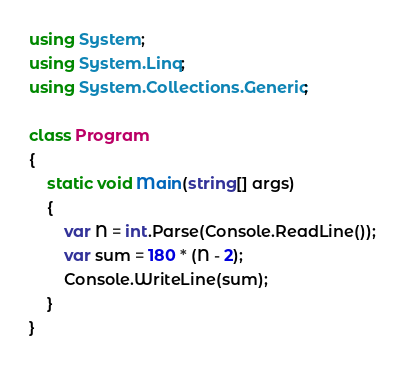<code> <loc_0><loc_0><loc_500><loc_500><_C#_>using System;
using System.Linq;
using System.Collections.Generic;

class Program
{
    static void Main(string[] args)
    {
        var N = int.Parse(Console.ReadLine());
        var sum = 180 * (N - 2);
        Console.WriteLine(sum);
    }
}

</code> 